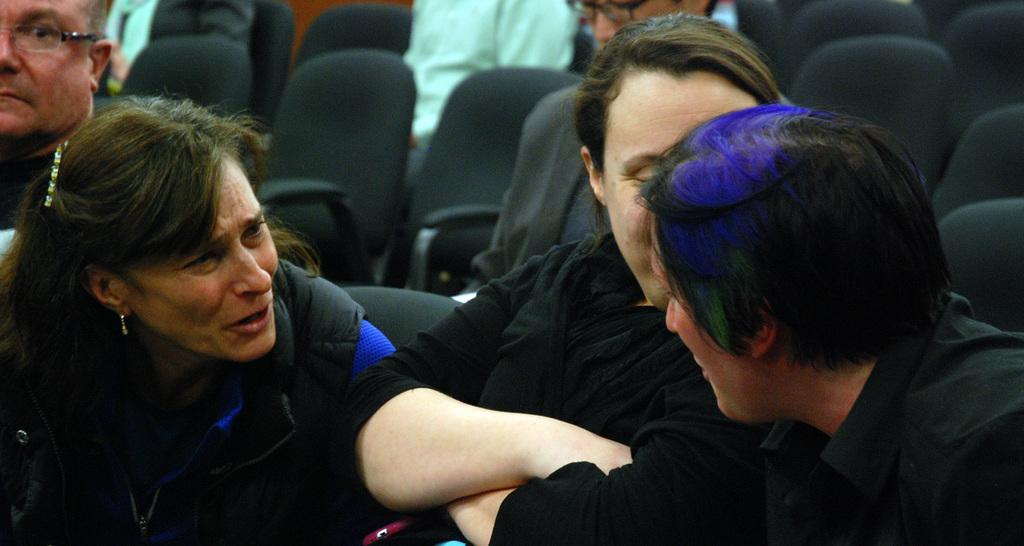What are the people in the image doing? The people in the image are seated in the chairs. How many chairs are visible in the image? There are empty chairs in the image. How many pies are being bitten by the daughter in the image? There is no daughter or pies present in the image. 